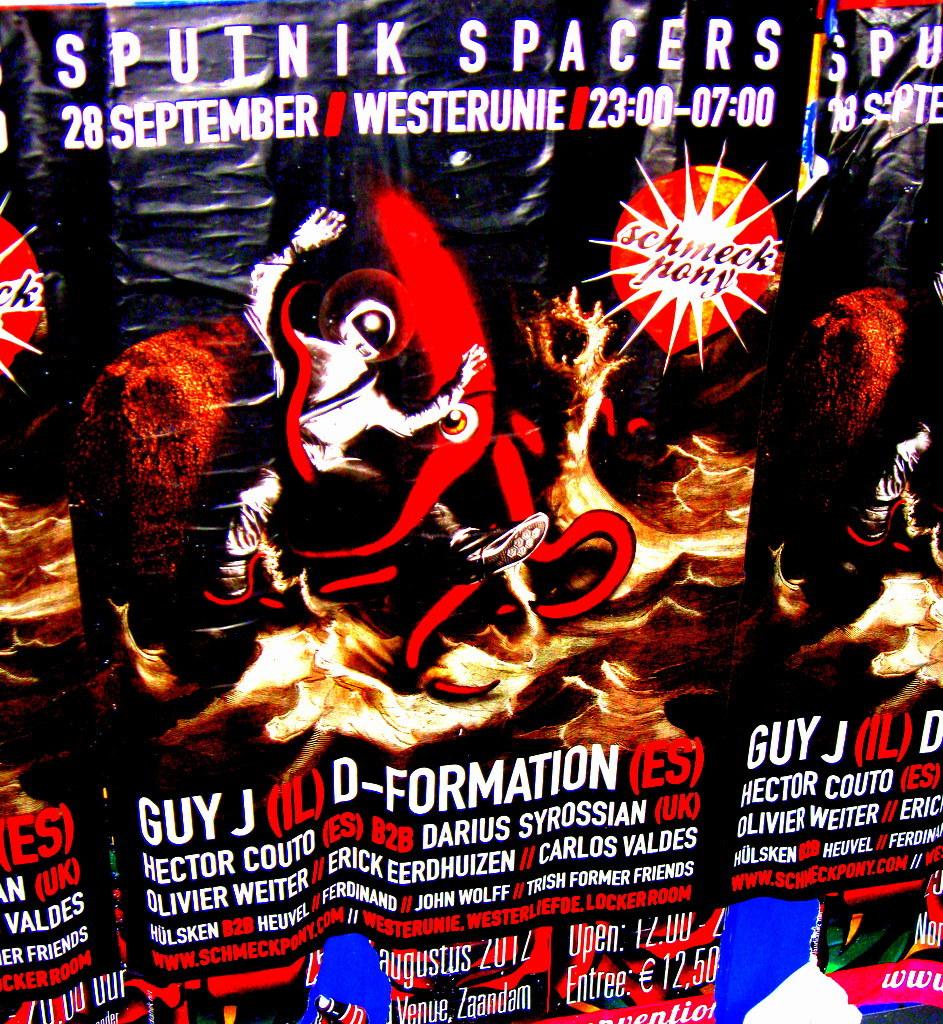What day is it on?
Your response must be concise. 28 september. What is this event called?
Make the answer very short. Sputnik spacers. 